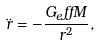<formula> <loc_0><loc_0><loc_500><loc_500>\ddot { r } = - \frac { G _ { e } f f M } { r ^ { 2 } } ,</formula> 